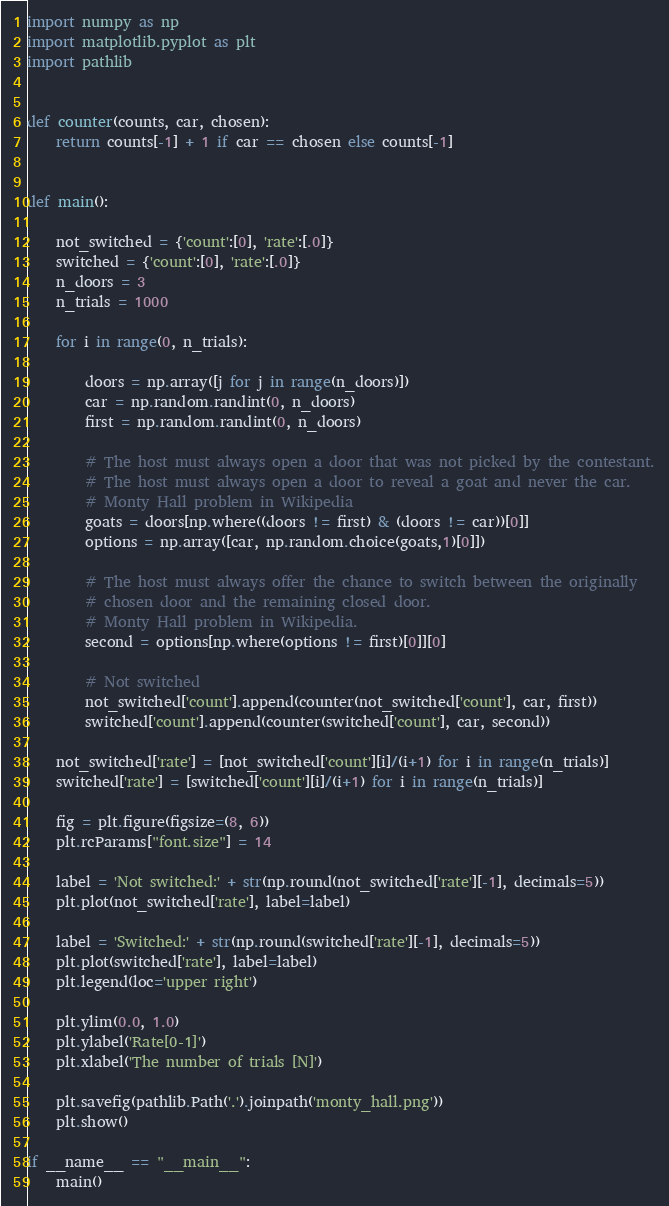Convert code to text. <code><loc_0><loc_0><loc_500><loc_500><_Python_>import numpy as np
import matplotlib.pyplot as plt
import pathlib


def counter(counts, car, chosen):
    return counts[-1] + 1 if car == chosen else counts[-1]


def main():
    
    not_switched = {'count':[0], 'rate':[.0]}
    switched = {'count':[0], 'rate':[.0]}
    n_doors = 3
    n_trials = 1000

    for i in range(0, n_trials):
        
        doors = np.array([j for j in range(n_doors)])
        car = np.random.randint(0, n_doors)
        first = np.random.randint(0, n_doors)

        # The host must always open a door that was not picked by the contestant.
        # The host must always open a door to reveal a goat and never the car.
        # Monty Hall problem in Wikipedia
        goats = doors[np.where((doors != first) & (doors != car))[0]]
        options = np.array([car, np.random.choice(goats,1)[0]])

        # The host must always offer the chance to switch between the originally
        # chosen door and the remaining closed door.
        # Monty Hall problem in Wikipedia.
        second = options[np.where(options != first)[0]][0]
        
        # Not switched
        not_switched['count'].append(counter(not_switched['count'], car, first))
        switched['count'].append(counter(switched['count'], car, second))

    not_switched['rate'] = [not_switched['count'][i]/(i+1) for i in range(n_trials)]
    switched['rate'] = [switched['count'][i]/(i+1) for i in range(n_trials)]

    fig = plt.figure(figsize=(8, 6))
    plt.rcParams["font.size"] = 14

    label = 'Not switched:' + str(np.round(not_switched['rate'][-1], decimals=5))
    plt.plot(not_switched['rate'], label=label)

    label = 'Switched:' + str(np.round(switched['rate'][-1], decimals=5))
    plt.plot(switched['rate'], label=label)
    plt.legend(loc='upper right')

    plt.ylim(0.0, 1.0)
    plt.ylabel('Rate[0-1]')
    plt.xlabel('The number of trials [N]')

    plt.savefig(pathlib.Path('.').joinpath('monty_hall.png'))
    plt.show()

if __name__ == "__main__":
    main()</code> 